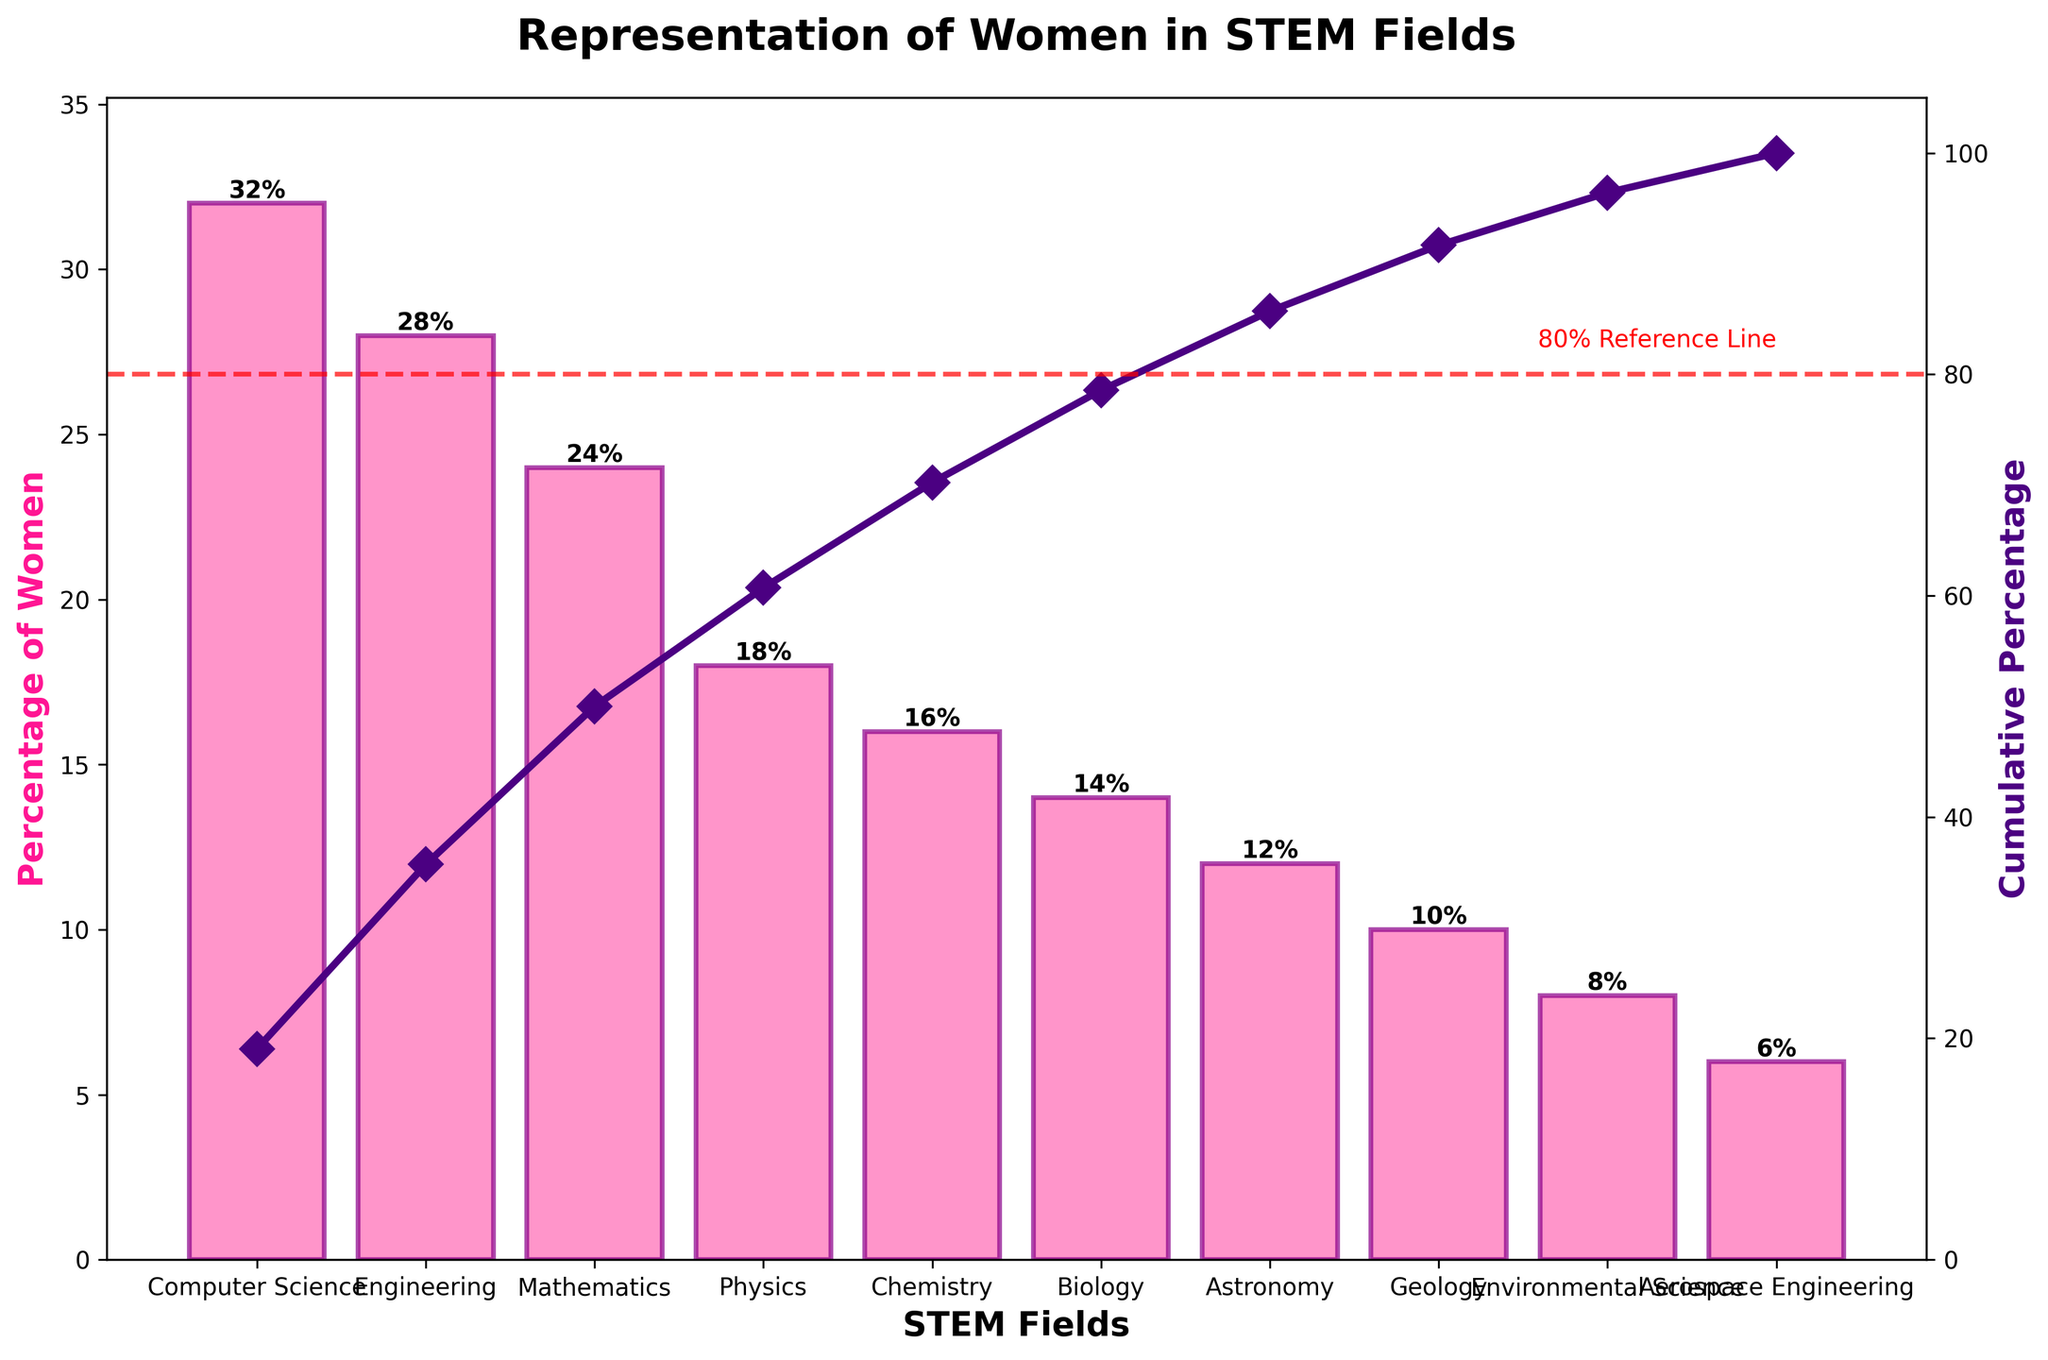Which STEM field has the highest percentage of women? The title of the chart is "Representation of Women in STEM Fields". Looking at the bars, the highest point is labeled "Computer Science" with a "percentage of women" value of 32%.
Answer: Computer Science Which field has the lowest percentage of women? By observing the lowest bar in the Pareto chart, it is labeled "Aerospace Engineering" with a percentage value of 6%.
Answer: Aerospace Engineering How many fields have a percentage of women less than 20%? By counting the bars with a "percentage of women" value less than 20%, we see fields: Physics, Chemistry, Biology, Astronomy, Geology, Environmental Science, and Aerospace Engineering. This totals 7 fields.
Answer: 7 fields What's the cumulative percentage after the top 3 fields? The cumulative percentage line reaches the third bar "Mathematics", which is listed as Computer Science (32%) + Engineering (28%) + Mathematics (24%), and the cumulative percentage shown close to the third bar is around 84%.
Answer: 84% Which fields fall on or above the 80% reference line? The cumulative percentage line crosses the 80% reference line at the third bar, labeled "Mathematics". Therefore, fields Computer Science, Engineering, and Mathematics are respectively on or above this line.
Answer: Computer Science, Engineering, Mathematics How much higher is the percentage of women in Computer Science compared to Environmental Science? The bar for Computer Science shows a percentage of 32%, while for Environmental Science it is 8%. By subtracting 8% from 32%, we find the difference to be 24%.
Answer: 24% Which field marks the transition point at which the cumulative percentage exceeds 50%? The cumulative line crosses the 50% mark at the second bar, labeled "Engineering".
Answer: Engineering How do the percentages of women in Physics and Chemistry compare? The bar for Physics shows a percentage of 18%, while the bar for Chemistry shows a percentage of 16%. Therefore, Physics has a slightly higher percentage of women than Chemistry.
Answer: Physics is higher by 2% What total percentage of women is represented by the fields Astronomy, Geology, Environmental Science, and Aerospace Engineering? Summing their percentages: Astronomy (12%) + Geology (10%) + Environmental Science (8%) + Aerospace Engineering (6%) equates to 36%.
Answer: 36% What is the percentage difference between the field with the highest and lowest representation of women? The highest percentage is Computer Science (32%) and the lowest is Aerospace Engineering (6%). Subtracting 6% from 32%, the difference is 26%.
Answer: 26% 